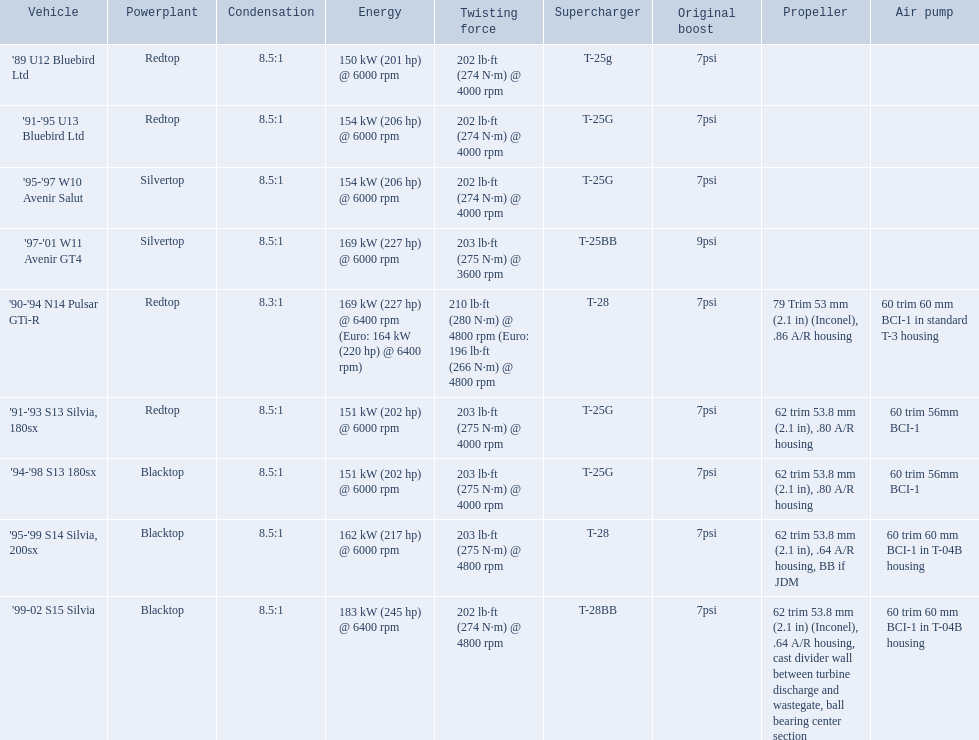What are the listed hp of the cars? 150 kW (201 hp) @ 6000 rpm, 154 kW (206 hp) @ 6000 rpm, 154 kW (206 hp) @ 6000 rpm, 169 kW (227 hp) @ 6000 rpm, 169 kW (227 hp) @ 6400 rpm (Euro: 164 kW (220 hp) @ 6400 rpm), 151 kW (202 hp) @ 6000 rpm, 151 kW (202 hp) @ 6000 rpm, 162 kW (217 hp) @ 6000 rpm, 183 kW (245 hp) @ 6400 rpm. Which is the only car with over 230 hp? '99-02 S15 Silvia. 